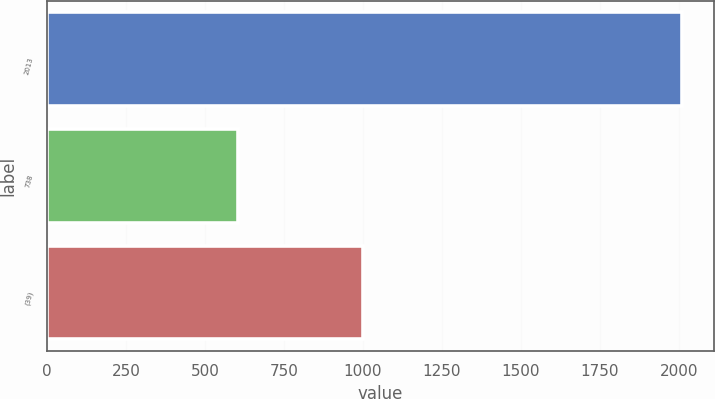Convert chart to OTSL. <chart><loc_0><loc_0><loc_500><loc_500><bar_chart><fcel>2013<fcel>738<fcel>(39)<nl><fcel>2011<fcel>606<fcel>1000<nl></chart> 